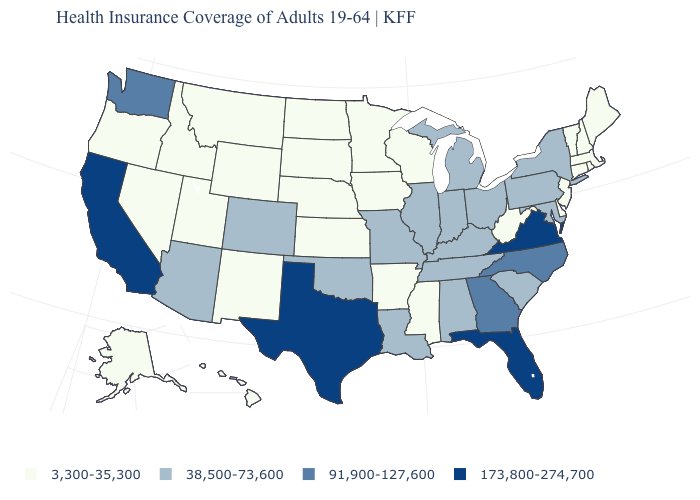Among the states that border South Carolina , which have the highest value?
Give a very brief answer. Georgia, North Carolina. Name the states that have a value in the range 38,500-73,600?
Write a very short answer. Alabama, Arizona, Colorado, Illinois, Indiana, Kentucky, Louisiana, Maryland, Michigan, Missouri, New York, Ohio, Oklahoma, Pennsylvania, South Carolina, Tennessee. What is the value of Maryland?
Concise answer only. 38,500-73,600. Which states have the lowest value in the USA?
Be succinct. Alaska, Arkansas, Connecticut, Delaware, Hawaii, Idaho, Iowa, Kansas, Maine, Massachusetts, Minnesota, Mississippi, Montana, Nebraska, Nevada, New Hampshire, New Jersey, New Mexico, North Dakota, Oregon, Rhode Island, South Dakota, Utah, Vermont, West Virginia, Wisconsin, Wyoming. Does Kansas have a lower value than Missouri?
Keep it brief. Yes. Which states have the lowest value in the West?
Quick response, please. Alaska, Hawaii, Idaho, Montana, Nevada, New Mexico, Oregon, Utah, Wyoming. Name the states that have a value in the range 91,900-127,600?
Quick response, please. Georgia, North Carolina, Washington. Name the states that have a value in the range 91,900-127,600?
Write a very short answer. Georgia, North Carolina, Washington. What is the lowest value in the USA?
Short answer required. 3,300-35,300. Does the first symbol in the legend represent the smallest category?
Answer briefly. Yes. What is the highest value in states that border Colorado?
Be succinct. 38,500-73,600. Does Delaware have the same value as Georgia?
Concise answer only. No. Does Wisconsin have the highest value in the MidWest?
Short answer required. No. Which states have the lowest value in the USA?
Write a very short answer. Alaska, Arkansas, Connecticut, Delaware, Hawaii, Idaho, Iowa, Kansas, Maine, Massachusetts, Minnesota, Mississippi, Montana, Nebraska, Nevada, New Hampshire, New Jersey, New Mexico, North Dakota, Oregon, Rhode Island, South Dakota, Utah, Vermont, West Virginia, Wisconsin, Wyoming. Does the first symbol in the legend represent the smallest category?
Be succinct. Yes. 